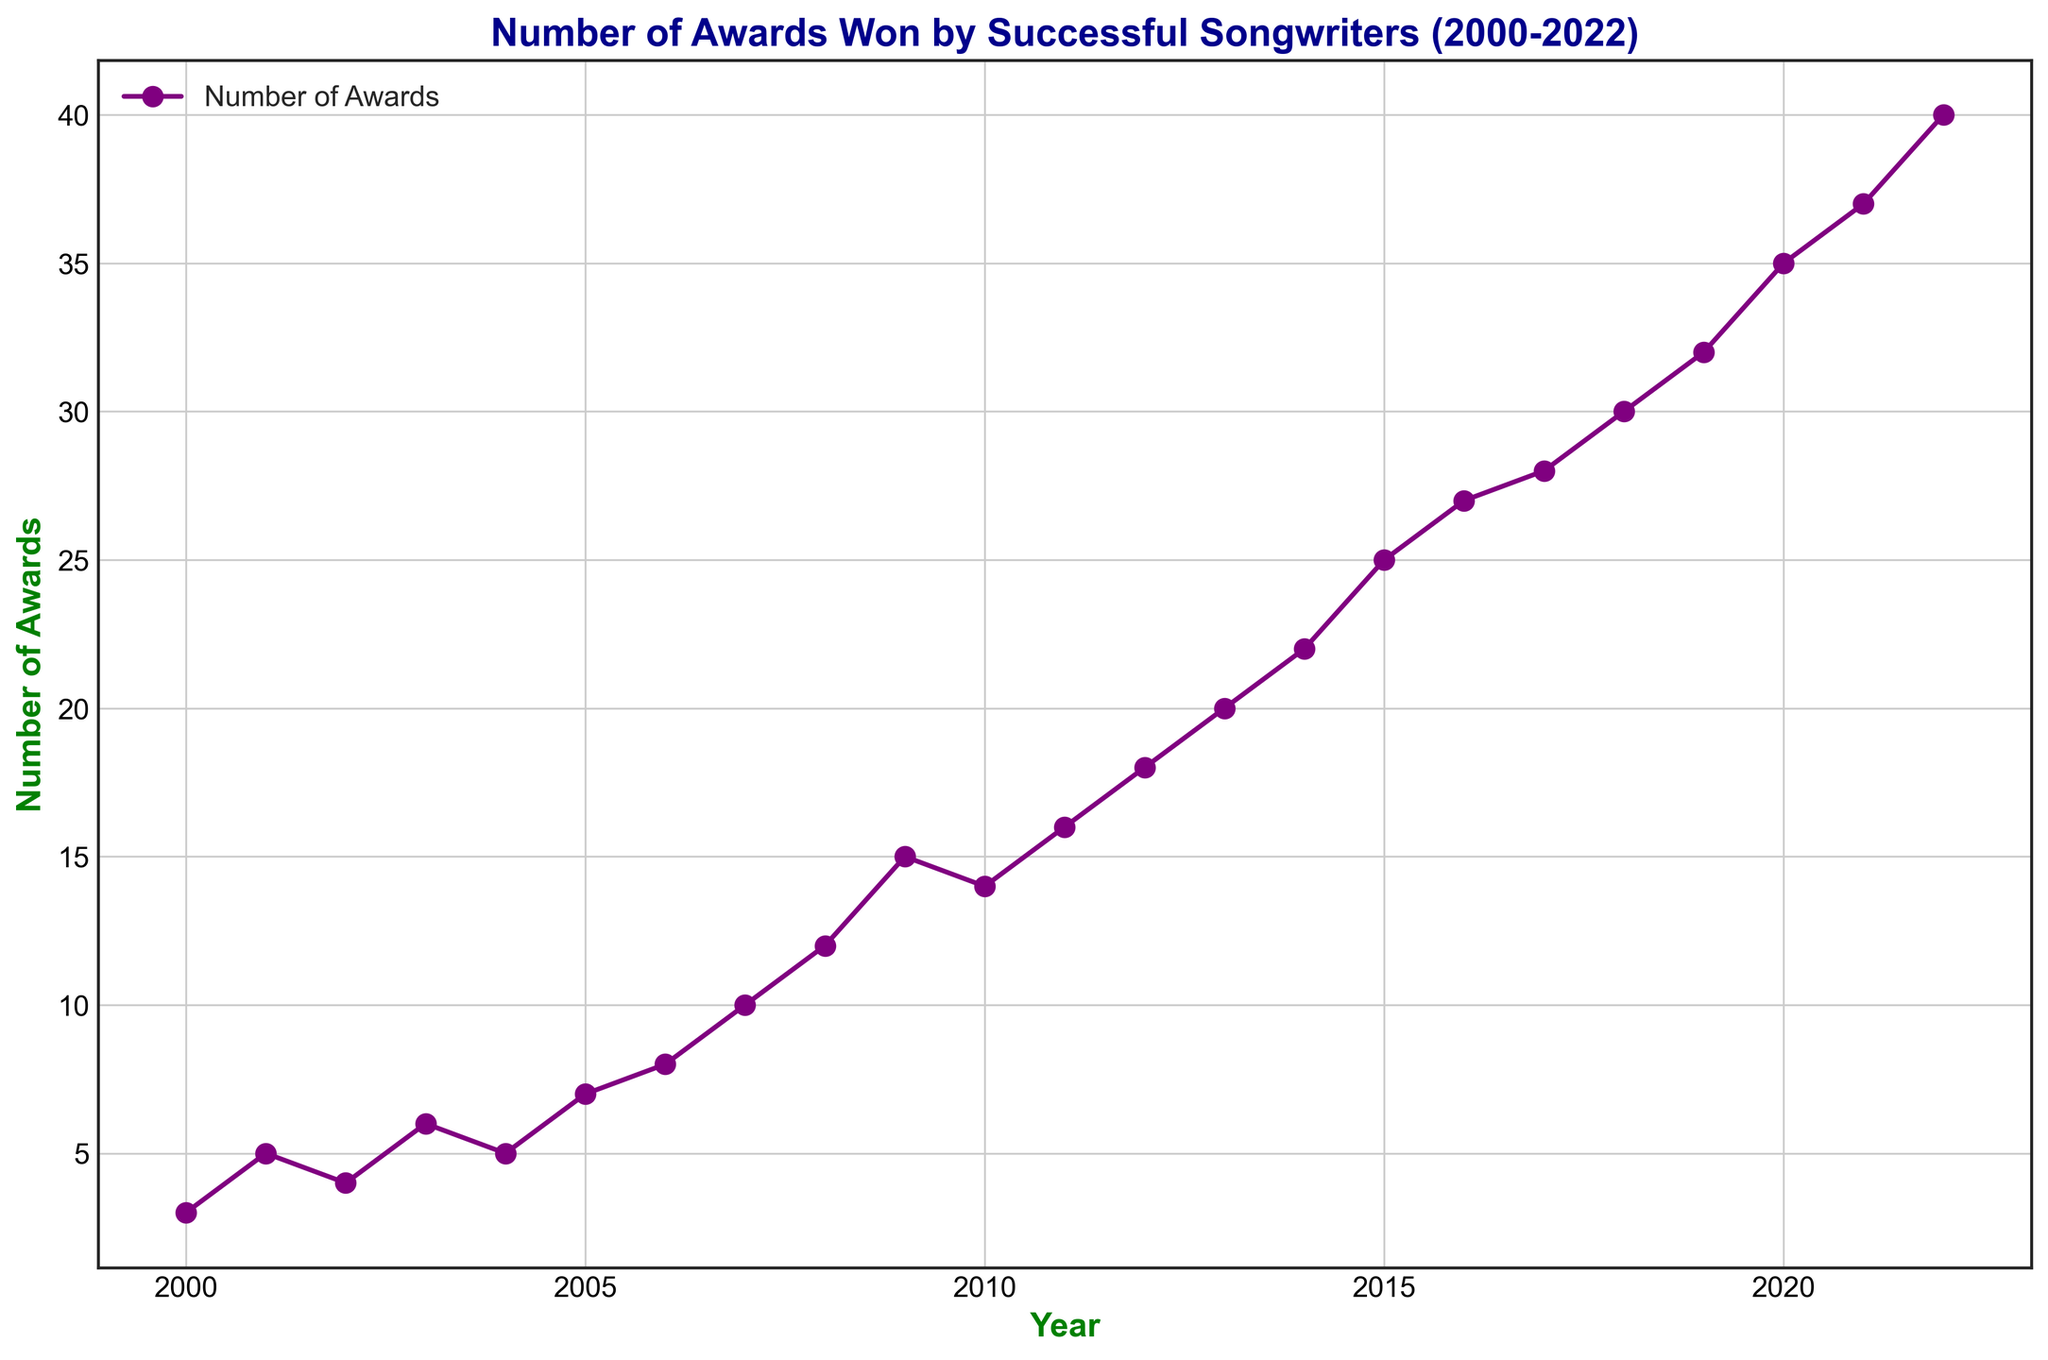what is the maximum number of awards won in a year? The plot shows the number of awards over time, and by examining it, we identify the highest value in the 'Number of Awards' axis. In 2022, the highest point on the chart is 40.
Answer: 40 In what year did the number of awards jump above 20 for the first time? Looking along the year axis, we need to identify when the values on the awards axis go over 20 for the first time. The chart shows that in 2014, the number reaches 22.
Answer: 2014 How many awards were won in total from 2000 to 2005? We need to sum the number of awards from 2000 to 2005. These values are 3, 5, 4, 6, 5, and 7 respectively. Summing these, 3 + 5 + 4 + 6 + 5 + 7 = 30.
Answer: 30 Which year saw the highest increase in the number of awards compared to the previous year? We must calculate the differences between successive years and identify the largest increase. The largest jump is between 2008 (12) and 2009 (15), with an increase of 3 awards.
Answer: 2009 Did the number of awards ever decrease between two consecutive years? We need to check for any point where an earlier year has more awards than the following year. The plot shows no such occurrences as the number of awards consistently increases or stays level.
Answer: No What was the average number of awards won per year from 2015 to 2020? Calculate the total awards from 2015 to 2020 and divide by the number of years (6). The awards are 25, 27, 28, 30, 32, and 35. Total = 25 + 27 + 28 + 30 + 32 + 35 = 177. Average = 177 / 6 ≈ 29.5.
Answer: 29.5 How many more awards were won in 2022 compared to 2000? Find the difference between the awards in 2022 and 2000. The awards in 2022 were 40, and in 2000 were 3. Difference = 40 - 3 = 37.
Answer: 37 Which year had the lowest number of awards after the year 2005? We need to look at the chart from 2006 onward and identify the year with the smallest number of awards. In 2006, the number of awards is 8, the lowest post-2005 by visual inspection.
Answer: 2006 Is there a visual mark indicating a period of rapid growth in awards? Identify any segment of the line chart where the line steepens significantly. The steepest increase appears visually between 2015 to 2018.
Answer: 2015 to 2018 